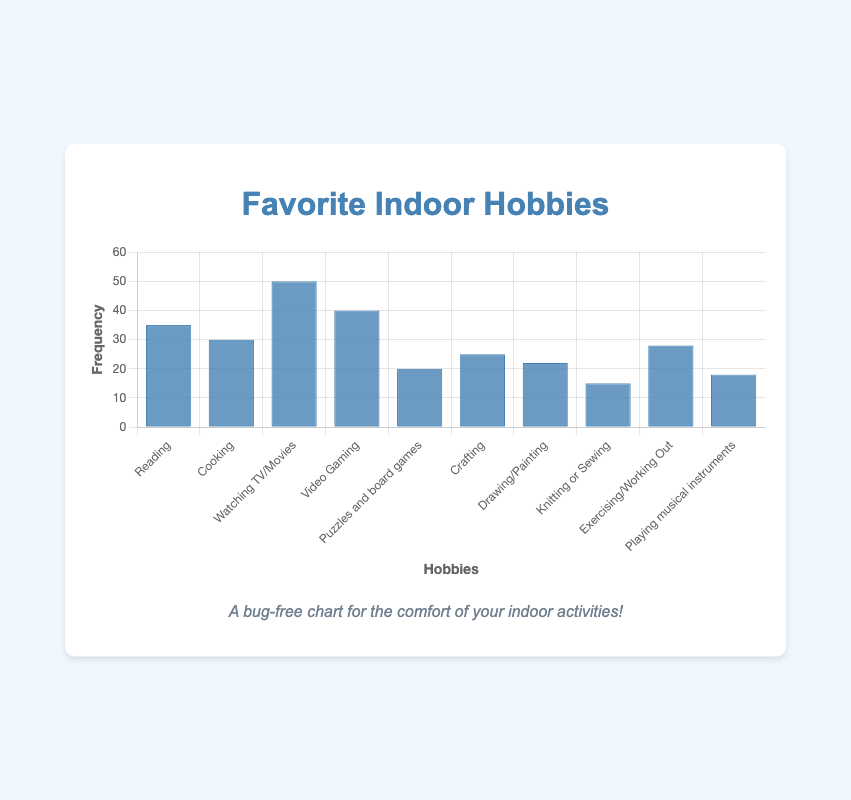Which hobby has the highest frequency in the chart? By visually inspecting the height of the bars, the tallest bar represents "Watching TV/Movies" with a frequency of 50.
Answer: Watching TV/Movies Which hobby has the lowest frequency in the chart? The shortest bar represents "Knitting or Sewing" with a frequency of 15.
Answer: Knitting or Sewing How much more frequent is "Video Gaming" compared to "Drawing/Painting"? "Video Gaming" has a frequency of 40, while "Drawing/Painting" has a frequency of 22. The difference is 40 - 22 = 18.
Answer: 18 What is the average frequency of the top three hobbies? The top three hobbies by frequency are "Watching TV/Movies" (50), "Video Gaming" (40), and "Reading" (35). The average frequency is (50 + 40 + 35) / 3 = 125 / 3 ≈ 41.67.
Answer: 41.67 Which hobby is more popular, "Cooking" or "Crafting"? By comparing the heights of the bars, "Cooking" has a frequency of 30, and "Crafting" has a frequency of 25. Therefore, "Cooking" is more popular.
Answer: Cooking How much is the total frequency of all hobbies combined? Summing up the frequencies of all hobbies: 35 (Reading) + 30 (Cooking) + 50 (Watching TV/Movies) + 40 (Video Gaming) + 20 (Puzzles and board games) + 25 (Crafting) + 22 (Drawing/Painting) + 15 (Knitting or Sewing) + 28 (Exercising/Working Out) + 18 (Playing musical instruments) = 283.
Answer: 283 What is the range of the frequencies? The range is the difference between the highest and lowest frequencies. The highest is "Watching TV/Movies" with 50, and the lowest is "Knitting or Sewing" with 15. So, the range is 50 - 15 = 35.
Answer: 35 What percentage of the total frequency does "Exercising/Working Out" represent? The total frequency is 283. "Exercising/Working Out" has a frequency of 28. The percentage is (28 / 283) * 100 ≈ 9.89%.
Answer: 9.89% 